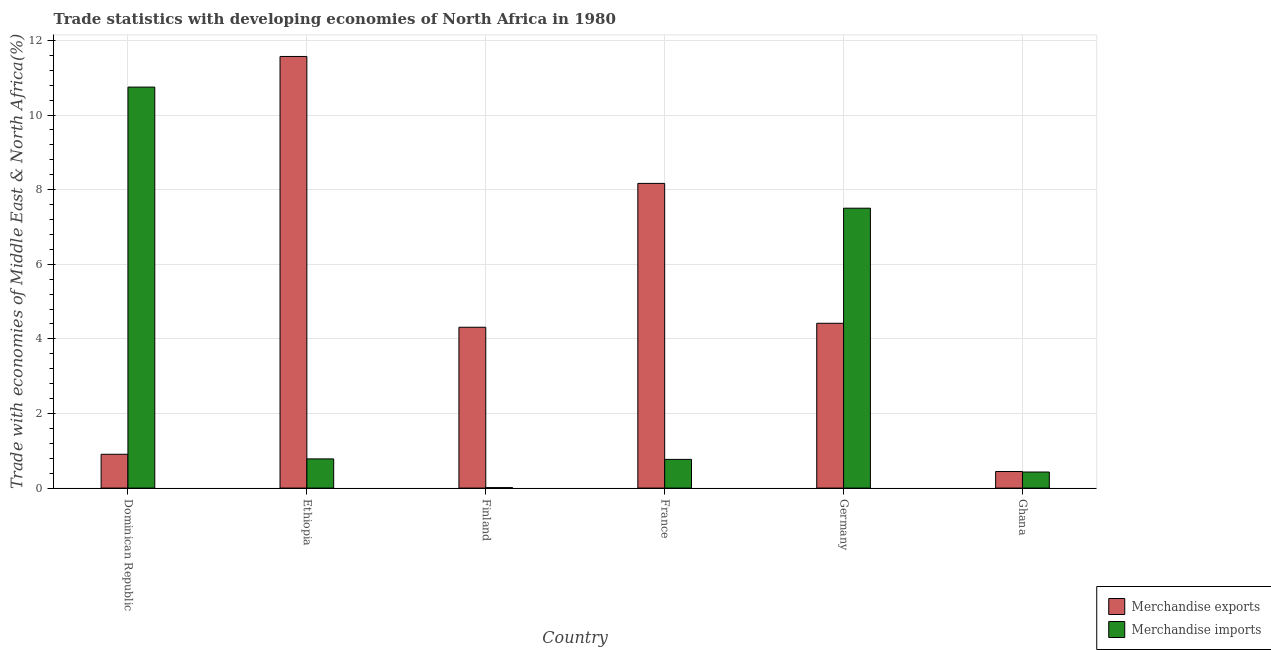How many different coloured bars are there?
Offer a very short reply. 2. How many groups of bars are there?
Your response must be concise. 6. Are the number of bars per tick equal to the number of legend labels?
Your answer should be compact. Yes. Are the number of bars on each tick of the X-axis equal?
Provide a short and direct response. Yes. How many bars are there on the 5th tick from the left?
Your response must be concise. 2. How many bars are there on the 2nd tick from the right?
Your response must be concise. 2. In how many cases, is the number of bars for a given country not equal to the number of legend labels?
Offer a terse response. 0. What is the merchandise exports in France?
Your response must be concise. 8.17. Across all countries, what is the maximum merchandise imports?
Provide a short and direct response. 10.75. Across all countries, what is the minimum merchandise imports?
Make the answer very short. 0.01. In which country was the merchandise imports maximum?
Your response must be concise. Dominican Republic. What is the total merchandise imports in the graph?
Make the answer very short. 20.25. What is the difference between the merchandise imports in Finland and that in France?
Provide a succinct answer. -0.76. What is the difference between the merchandise exports in Ghana and the merchandise imports in France?
Your answer should be very brief. -0.33. What is the average merchandise exports per country?
Give a very brief answer. 4.97. What is the difference between the merchandise imports and merchandise exports in Germany?
Provide a succinct answer. 3.08. In how many countries, is the merchandise exports greater than 8.4 %?
Make the answer very short. 1. What is the ratio of the merchandise imports in Ethiopia to that in Ghana?
Make the answer very short. 1.82. Is the merchandise exports in France less than that in Germany?
Your answer should be very brief. No. Is the difference between the merchandise exports in Ethiopia and France greater than the difference between the merchandise imports in Ethiopia and France?
Your answer should be compact. Yes. What is the difference between the highest and the second highest merchandise exports?
Your response must be concise. 3.4. What is the difference between the highest and the lowest merchandise imports?
Your answer should be compact. 10.74. In how many countries, is the merchandise imports greater than the average merchandise imports taken over all countries?
Make the answer very short. 2. Is the sum of the merchandise imports in Dominican Republic and Ethiopia greater than the maximum merchandise exports across all countries?
Your answer should be compact. No. What does the 2nd bar from the left in Ethiopia represents?
Provide a succinct answer. Merchandise imports. What does the 2nd bar from the right in Dominican Republic represents?
Give a very brief answer. Merchandise exports. How many bars are there?
Provide a short and direct response. 12. What is the difference between two consecutive major ticks on the Y-axis?
Offer a very short reply. 2. Does the graph contain grids?
Make the answer very short. Yes. Where does the legend appear in the graph?
Ensure brevity in your answer.  Bottom right. How many legend labels are there?
Provide a short and direct response. 2. How are the legend labels stacked?
Your answer should be very brief. Vertical. What is the title of the graph?
Give a very brief answer. Trade statistics with developing economies of North Africa in 1980. Does "Register a property" appear as one of the legend labels in the graph?
Provide a succinct answer. No. What is the label or title of the Y-axis?
Your answer should be very brief. Trade with economies of Middle East & North Africa(%). What is the Trade with economies of Middle East & North Africa(%) of Merchandise exports in Dominican Republic?
Provide a short and direct response. 0.91. What is the Trade with economies of Middle East & North Africa(%) in Merchandise imports in Dominican Republic?
Ensure brevity in your answer.  10.75. What is the Trade with economies of Middle East & North Africa(%) of Merchandise exports in Ethiopia?
Keep it short and to the point. 11.57. What is the Trade with economies of Middle East & North Africa(%) of Merchandise imports in Ethiopia?
Your answer should be compact. 0.78. What is the Trade with economies of Middle East & North Africa(%) in Merchandise exports in Finland?
Ensure brevity in your answer.  4.31. What is the Trade with economies of Middle East & North Africa(%) in Merchandise imports in Finland?
Offer a very short reply. 0.01. What is the Trade with economies of Middle East & North Africa(%) of Merchandise exports in France?
Ensure brevity in your answer.  8.17. What is the Trade with economies of Middle East & North Africa(%) of Merchandise imports in France?
Make the answer very short. 0.77. What is the Trade with economies of Middle East & North Africa(%) in Merchandise exports in Germany?
Your answer should be very brief. 4.42. What is the Trade with economies of Middle East & North Africa(%) in Merchandise imports in Germany?
Your answer should be compact. 7.5. What is the Trade with economies of Middle East & North Africa(%) of Merchandise exports in Ghana?
Provide a short and direct response. 0.44. What is the Trade with economies of Middle East & North Africa(%) in Merchandise imports in Ghana?
Make the answer very short. 0.43. Across all countries, what is the maximum Trade with economies of Middle East & North Africa(%) of Merchandise exports?
Offer a terse response. 11.57. Across all countries, what is the maximum Trade with economies of Middle East & North Africa(%) of Merchandise imports?
Ensure brevity in your answer.  10.75. Across all countries, what is the minimum Trade with economies of Middle East & North Africa(%) of Merchandise exports?
Offer a terse response. 0.44. Across all countries, what is the minimum Trade with economies of Middle East & North Africa(%) in Merchandise imports?
Give a very brief answer. 0.01. What is the total Trade with economies of Middle East & North Africa(%) in Merchandise exports in the graph?
Make the answer very short. 29.82. What is the total Trade with economies of Middle East & North Africa(%) in Merchandise imports in the graph?
Give a very brief answer. 20.25. What is the difference between the Trade with economies of Middle East & North Africa(%) in Merchandise exports in Dominican Republic and that in Ethiopia?
Offer a very short reply. -10.66. What is the difference between the Trade with economies of Middle East & North Africa(%) of Merchandise imports in Dominican Republic and that in Ethiopia?
Your response must be concise. 9.97. What is the difference between the Trade with economies of Middle East & North Africa(%) in Merchandise exports in Dominican Republic and that in Finland?
Offer a terse response. -3.4. What is the difference between the Trade with economies of Middle East & North Africa(%) of Merchandise imports in Dominican Republic and that in Finland?
Your answer should be very brief. 10.74. What is the difference between the Trade with economies of Middle East & North Africa(%) in Merchandise exports in Dominican Republic and that in France?
Your answer should be very brief. -7.26. What is the difference between the Trade with economies of Middle East & North Africa(%) in Merchandise imports in Dominican Republic and that in France?
Your response must be concise. 9.98. What is the difference between the Trade with economies of Middle East & North Africa(%) of Merchandise exports in Dominican Republic and that in Germany?
Offer a terse response. -3.51. What is the difference between the Trade with economies of Middle East & North Africa(%) of Merchandise imports in Dominican Republic and that in Germany?
Your answer should be very brief. 3.25. What is the difference between the Trade with economies of Middle East & North Africa(%) in Merchandise exports in Dominican Republic and that in Ghana?
Keep it short and to the point. 0.46. What is the difference between the Trade with economies of Middle East & North Africa(%) of Merchandise imports in Dominican Republic and that in Ghana?
Make the answer very short. 10.32. What is the difference between the Trade with economies of Middle East & North Africa(%) of Merchandise exports in Ethiopia and that in Finland?
Give a very brief answer. 7.26. What is the difference between the Trade with economies of Middle East & North Africa(%) in Merchandise imports in Ethiopia and that in Finland?
Your answer should be very brief. 0.77. What is the difference between the Trade with economies of Middle East & North Africa(%) of Merchandise exports in Ethiopia and that in France?
Make the answer very short. 3.4. What is the difference between the Trade with economies of Middle East & North Africa(%) of Merchandise imports in Ethiopia and that in France?
Ensure brevity in your answer.  0.01. What is the difference between the Trade with economies of Middle East & North Africa(%) of Merchandise exports in Ethiopia and that in Germany?
Offer a very short reply. 7.15. What is the difference between the Trade with economies of Middle East & North Africa(%) of Merchandise imports in Ethiopia and that in Germany?
Provide a succinct answer. -6.72. What is the difference between the Trade with economies of Middle East & North Africa(%) in Merchandise exports in Ethiopia and that in Ghana?
Ensure brevity in your answer.  11.13. What is the difference between the Trade with economies of Middle East & North Africa(%) of Merchandise imports in Ethiopia and that in Ghana?
Make the answer very short. 0.35. What is the difference between the Trade with economies of Middle East & North Africa(%) of Merchandise exports in Finland and that in France?
Provide a short and direct response. -3.86. What is the difference between the Trade with economies of Middle East & North Africa(%) in Merchandise imports in Finland and that in France?
Give a very brief answer. -0.76. What is the difference between the Trade with economies of Middle East & North Africa(%) in Merchandise exports in Finland and that in Germany?
Provide a short and direct response. -0.11. What is the difference between the Trade with economies of Middle East & North Africa(%) in Merchandise imports in Finland and that in Germany?
Provide a short and direct response. -7.49. What is the difference between the Trade with economies of Middle East & North Africa(%) of Merchandise exports in Finland and that in Ghana?
Keep it short and to the point. 3.87. What is the difference between the Trade with economies of Middle East & North Africa(%) in Merchandise imports in Finland and that in Ghana?
Keep it short and to the point. -0.42. What is the difference between the Trade with economies of Middle East & North Africa(%) of Merchandise exports in France and that in Germany?
Offer a very short reply. 3.75. What is the difference between the Trade with economies of Middle East & North Africa(%) in Merchandise imports in France and that in Germany?
Make the answer very short. -6.73. What is the difference between the Trade with economies of Middle East & North Africa(%) of Merchandise exports in France and that in Ghana?
Give a very brief answer. 7.72. What is the difference between the Trade with economies of Middle East & North Africa(%) of Merchandise imports in France and that in Ghana?
Keep it short and to the point. 0.34. What is the difference between the Trade with economies of Middle East & North Africa(%) of Merchandise exports in Germany and that in Ghana?
Your answer should be very brief. 3.97. What is the difference between the Trade with economies of Middle East & North Africa(%) of Merchandise imports in Germany and that in Ghana?
Offer a terse response. 7.07. What is the difference between the Trade with economies of Middle East & North Africa(%) in Merchandise exports in Dominican Republic and the Trade with economies of Middle East & North Africa(%) in Merchandise imports in Ethiopia?
Ensure brevity in your answer.  0.12. What is the difference between the Trade with economies of Middle East & North Africa(%) of Merchandise exports in Dominican Republic and the Trade with economies of Middle East & North Africa(%) of Merchandise imports in Finland?
Provide a succinct answer. 0.89. What is the difference between the Trade with economies of Middle East & North Africa(%) in Merchandise exports in Dominican Republic and the Trade with economies of Middle East & North Africa(%) in Merchandise imports in France?
Your answer should be very brief. 0.14. What is the difference between the Trade with economies of Middle East & North Africa(%) of Merchandise exports in Dominican Republic and the Trade with economies of Middle East & North Africa(%) of Merchandise imports in Germany?
Your answer should be compact. -6.6. What is the difference between the Trade with economies of Middle East & North Africa(%) in Merchandise exports in Dominican Republic and the Trade with economies of Middle East & North Africa(%) in Merchandise imports in Ghana?
Provide a short and direct response. 0.48. What is the difference between the Trade with economies of Middle East & North Africa(%) of Merchandise exports in Ethiopia and the Trade with economies of Middle East & North Africa(%) of Merchandise imports in Finland?
Ensure brevity in your answer.  11.56. What is the difference between the Trade with economies of Middle East & North Africa(%) of Merchandise exports in Ethiopia and the Trade with economies of Middle East & North Africa(%) of Merchandise imports in France?
Offer a terse response. 10.8. What is the difference between the Trade with economies of Middle East & North Africa(%) in Merchandise exports in Ethiopia and the Trade with economies of Middle East & North Africa(%) in Merchandise imports in Germany?
Your answer should be very brief. 4.07. What is the difference between the Trade with economies of Middle East & North Africa(%) in Merchandise exports in Ethiopia and the Trade with economies of Middle East & North Africa(%) in Merchandise imports in Ghana?
Provide a short and direct response. 11.14. What is the difference between the Trade with economies of Middle East & North Africa(%) in Merchandise exports in Finland and the Trade with economies of Middle East & North Africa(%) in Merchandise imports in France?
Your answer should be very brief. 3.54. What is the difference between the Trade with economies of Middle East & North Africa(%) of Merchandise exports in Finland and the Trade with economies of Middle East & North Africa(%) of Merchandise imports in Germany?
Your response must be concise. -3.19. What is the difference between the Trade with economies of Middle East & North Africa(%) in Merchandise exports in Finland and the Trade with economies of Middle East & North Africa(%) in Merchandise imports in Ghana?
Keep it short and to the point. 3.88. What is the difference between the Trade with economies of Middle East & North Africa(%) of Merchandise exports in France and the Trade with economies of Middle East & North Africa(%) of Merchandise imports in Germany?
Give a very brief answer. 0.66. What is the difference between the Trade with economies of Middle East & North Africa(%) in Merchandise exports in France and the Trade with economies of Middle East & North Africa(%) in Merchandise imports in Ghana?
Your answer should be compact. 7.74. What is the difference between the Trade with economies of Middle East & North Africa(%) of Merchandise exports in Germany and the Trade with economies of Middle East & North Africa(%) of Merchandise imports in Ghana?
Provide a succinct answer. 3.99. What is the average Trade with economies of Middle East & North Africa(%) of Merchandise exports per country?
Keep it short and to the point. 4.97. What is the average Trade with economies of Middle East & North Africa(%) in Merchandise imports per country?
Provide a short and direct response. 3.37. What is the difference between the Trade with economies of Middle East & North Africa(%) of Merchandise exports and Trade with economies of Middle East & North Africa(%) of Merchandise imports in Dominican Republic?
Give a very brief answer. -9.84. What is the difference between the Trade with economies of Middle East & North Africa(%) in Merchandise exports and Trade with economies of Middle East & North Africa(%) in Merchandise imports in Ethiopia?
Offer a terse response. 10.79. What is the difference between the Trade with economies of Middle East & North Africa(%) of Merchandise exports and Trade with economies of Middle East & North Africa(%) of Merchandise imports in Finland?
Offer a very short reply. 4.3. What is the difference between the Trade with economies of Middle East & North Africa(%) of Merchandise exports and Trade with economies of Middle East & North Africa(%) of Merchandise imports in France?
Your answer should be compact. 7.4. What is the difference between the Trade with economies of Middle East & North Africa(%) in Merchandise exports and Trade with economies of Middle East & North Africa(%) in Merchandise imports in Germany?
Keep it short and to the point. -3.08. What is the difference between the Trade with economies of Middle East & North Africa(%) in Merchandise exports and Trade with economies of Middle East & North Africa(%) in Merchandise imports in Ghana?
Offer a terse response. 0.01. What is the ratio of the Trade with economies of Middle East & North Africa(%) in Merchandise exports in Dominican Republic to that in Ethiopia?
Provide a short and direct response. 0.08. What is the ratio of the Trade with economies of Middle East & North Africa(%) in Merchandise imports in Dominican Republic to that in Ethiopia?
Keep it short and to the point. 13.74. What is the ratio of the Trade with economies of Middle East & North Africa(%) of Merchandise exports in Dominican Republic to that in Finland?
Offer a terse response. 0.21. What is the ratio of the Trade with economies of Middle East & North Africa(%) of Merchandise imports in Dominican Republic to that in Finland?
Offer a terse response. 848.85. What is the ratio of the Trade with economies of Middle East & North Africa(%) of Merchandise exports in Dominican Republic to that in France?
Provide a short and direct response. 0.11. What is the ratio of the Trade with economies of Middle East & North Africa(%) in Merchandise imports in Dominican Republic to that in France?
Offer a terse response. 13.97. What is the ratio of the Trade with economies of Middle East & North Africa(%) of Merchandise exports in Dominican Republic to that in Germany?
Make the answer very short. 0.21. What is the ratio of the Trade with economies of Middle East & North Africa(%) in Merchandise imports in Dominican Republic to that in Germany?
Make the answer very short. 1.43. What is the ratio of the Trade with economies of Middle East & North Africa(%) in Merchandise exports in Dominican Republic to that in Ghana?
Keep it short and to the point. 2.04. What is the ratio of the Trade with economies of Middle East & North Africa(%) in Merchandise imports in Dominican Republic to that in Ghana?
Keep it short and to the point. 24.97. What is the ratio of the Trade with economies of Middle East & North Africa(%) in Merchandise exports in Ethiopia to that in Finland?
Your answer should be very brief. 2.68. What is the ratio of the Trade with economies of Middle East & North Africa(%) in Merchandise imports in Ethiopia to that in Finland?
Give a very brief answer. 61.78. What is the ratio of the Trade with economies of Middle East & North Africa(%) in Merchandise exports in Ethiopia to that in France?
Your response must be concise. 1.42. What is the ratio of the Trade with economies of Middle East & North Africa(%) of Merchandise imports in Ethiopia to that in France?
Your response must be concise. 1.02. What is the ratio of the Trade with economies of Middle East & North Africa(%) in Merchandise exports in Ethiopia to that in Germany?
Your answer should be very brief. 2.62. What is the ratio of the Trade with economies of Middle East & North Africa(%) of Merchandise imports in Ethiopia to that in Germany?
Provide a succinct answer. 0.1. What is the ratio of the Trade with economies of Middle East & North Africa(%) in Merchandise exports in Ethiopia to that in Ghana?
Provide a succinct answer. 26.05. What is the ratio of the Trade with economies of Middle East & North Africa(%) in Merchandise imports in Ethiopia to that in Ghana?
Your answer should be very brief. 1.82. What is the ratio of the Trade with economies of Middle East & North Africa(%) in Merchandise exports in Finland to that in France?
Your response must be concise. 0.53. What is the ratio of the Trade with economies of Middle East & North Africa(%) in Merchandise imports in Finland to that in France?
Keep it short and to the point. 0.02. What is the ratio of the Trade with economies of Middle East & North Africa(%) of Merchandise exports in Finland to that in Germany?
Keep it short and to the point. 0.98. What is the ratio of the Trade with economies of Middle East & North Africa(%) in Merchandise imports in Finland to that in Germany?
Give a very brief answer. 0. What is the ratio of the Trade with economies of Middle East & North Africa(%) in Merchandise exports in Finland to that in Ghana?
Your response must be concise. 9.71. What is the ratio of the Trade with economies of Middle East & North Africa(%) in Merchandise imports in Finland to that in Ghana?
Provide a succinct answer. 0.03. What is the ratio of the Trade with economies of Middle East & North Africa(%) in Merchandise exports in France to that in Germany?
Provide a short and direct response. 1.85. What is the ratio of the Trade with economies of Middle East & North Africa(%) of Merchandise imports in France to that in Germany?
Offer a terse response. 0.1. What is the ratio of the Trade with economies of Middle East & North Africa(%) in Merchandise exports in France to that in Ghana?
Keep it short and to the point. 18.39. What is the ratio of the Trade with economies of Middle East & North Africa(%) in Merchandise imports in France to that in Ghana?
Make the answer very short. 1.79. What is the ratio of the Trade with economies of Middle East & North Africa(%) of Merchandise exports in Germany to that in Ghana?
Make the answer very short. 9.95. What is the ratio of the Trade with economies of Middle East & North Africa(%) of Merchandise imports in Germany to that in Ghana?
Offer a terse response. 17.43. What is the difference between the highest and the second highest Trade with economies of Middle East & North Africa(%) of Merchandise exports?
Offer a very short reply. 3.4. What is the difference between the highest and the second highest Trade with economies of Middle East & North Africa(%) of Merchandise imports?
Make the answer very short. 3.25. What is the difference between the highest and the lowest Trade with economies of Middle East & North Africa(%) of Merchandise exports?
Ensure brevity in your answer.  11.13. What is the difference between the highest and the lowest Trade with economies of Middle East & North Africa(%) in Merchandise imports?
Make the answer very short. 10.74. 